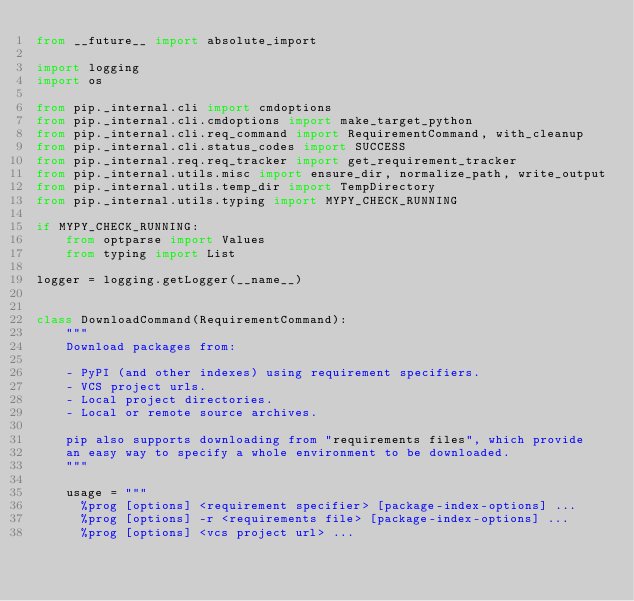Convert code to text. <code><loc_0><loc_0><loc_500><loc_500><_Python_>from __future__ import absolute_import

import logging
import os

from pip._internal.cli import cmdoptions
from pip._internal.cli.cmdoptions import make_target_python
from pip._internal.cli.req_command import RequirementCommand, with_cleanup
from pip._internal.cli.status_codes import SUCCESS
from pip._internal.req.req_tracker import get_requirement_tracker
from pip._internal.utils.misc import ensure_dir, normalize_path, write_output
from pip._internal.utils.temp_dir import TempDirectory
from pip._internal.utils.typing import MYPY_CHECK_RUNNING

if MYPY_CHECK_RUNNING:
    from optparse import Values
    from typing import List

logger = logging.getLogger(__name__)


class DownloadCommand(RequirementCommand):
    """
    Download packages from:

    - PyPI (and other indexes) using requirement specifiers.
    - VCS project urls.
    - Local project directories.
    - Local or remote source archives.

    pip also supports downloading from "requirements files", which provide
    an easy way to specify a whole environment to be downloaded.
    """

    usage = """
      %prog [options] <requirement specifier> [package-index-options] ...
      %prog [options] -r <requirements file> [package-index-options] ...
      %prog [options] <vcs project url> ...</code> 